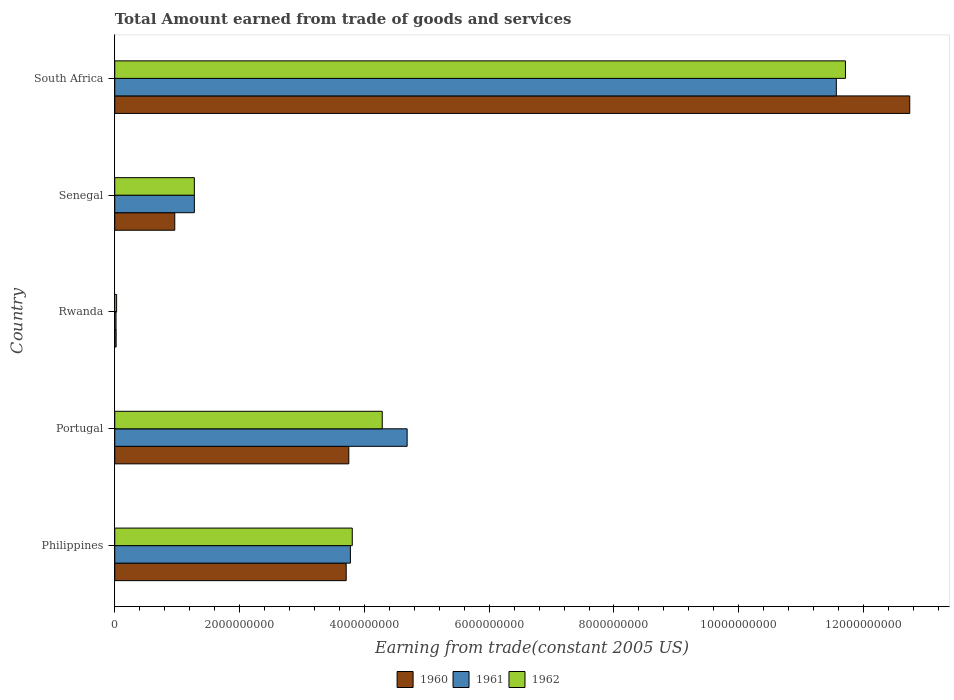How many groups of bars are there?
Your answer should be compact. 5. Are the number of bars per tick equal to the number of legend labels?
Provide a succinct answer. Yes. Are the number of bars on each tick of the Y-axis equal?
Your answer should be very brief. Yes. How many bars are there on the 3rd tick from the bottom?
Keep it short and to the point. 3. What is the label of the 1st group of bars from the top?
Provide a succinct answer. South Africa. In how many cases, is the number of bars for a given country not equal to the number of legend labels?
Your answer should be very brief. 0. What is the total amount earned by trading goods and services in 1962 in South Africa?
Provide a short and direct response. 1.17e+1. Across all countries, what is the maximum total amount earned by trading goods and services in 1961?
Your answer should be very brief. 1.16e+1. Across all countries, what is the minimum total amount earned by trading goods and services in 1962?
Provide a succinct answer. 2.97e+07. In which country was the total amount earned by trading goods and services in 1962 maximum?
Your response must be concise. South Africa. In which country was the total amount earned by trading goods and services in 1962 minimum?
Make the answer very short. Rwanda. What is the total total amount earned by trading goods and services in 1960 in the graph?
Offer a very short reply. 2.12e+1. What is the difference between the total amount earned by trading goods and services in 1962 in Philippines and that in South Africa?
Provide a succinct answer. -7.90e+09. What is the difference between the total amount earned by trading goods and services in 1960 in Philippines and the total amount earned by trading goods and services in 1961 in Portugal?
Your answer should be very brief. -9.77e+08. What is the average total amount earned by trading goods and services in 1960 per country?
Provide a short and direct response. 4.24e+09. What is the difference between the total amount earned by trading goods and services in 1961 and total amount earned by trading goods and services in 1962 in Rwanda?
Your answer should be compact. -9.20e+06. In how many countries, is the total amount earned by trading goods and services in 1961 greater than 6000000000 US$?
Provide a short and direct response. 1. What is the ratio of the total amount earned by trading goods and services in 1962 in Portugal to that in Rwanda?
Offer a terse response. 144.33. Is the total amount earned by trading goods and services in 1960 in Philippines less than that in Portugal?
Provide a succinct answer. Yes. What is the difference between the highest and the second highest total amount earned by trading goods and services in 1962?
Your answer should be very brief. 7.42e+09. What is the difference between the highest and the lowest total amount earned by trading goods and services in 1960?
Give a very brief answer. 1.27e+1. In how many countries, is the total amount earned by trading goods and services in 1960 greater than the average total amount earned by trading goods and services in 1960 taken over all countries?
Ensure brevity in your answer.  1. What does the 1st bar from the top in Philippines represents?
Your answer should be compact. 1962. What does the 3rd bar from the bottom in Rwanda represents?
Your answer should be compact. 1962. Is it the case that in every country, the sum of the total amount earned by trading goods and services in 1961 and total amount earned by trading goods and services in 1960 is greater than the total amount earned by trading goods and services in 1962?
Your answer should be very brief. Yes. How many bars are there?
Give a very brief answer. 15. How many countries are there in the graph?
Your answer should be very brief. 5. What is the difference between two consecutive major ticks on the X-axis?
Make the answer very short. 2.00e+09. Are the values on the major ticks of X-axis written in scientific E-notation?
Your answer should be very brief. No. Does the graph contain any zero values?
Offer a terse response. No. Does the graph contain grids?
Provide a succinct answer. No. Where does the legend appear in the graph?
Your answer should be very brief. Bottom center. How many legend labels are there?
Offer a terse response. 3. How are the legend labels stacked?
Keep it short and to the point. Horizontal. What is the title of the graph?
Provide a short and direct response. Total Amount earned from trade of goods and services. What is the label or title of the X-axis?
Ensure brevity in your answer.  Earning from trade(constant 2005 US). What is the Earning from trade(constant 2005 US) of 1960 in Philippines?
Offer a terse response. 3.71e+09. What is the Earning from trade(constant 2005 US) of 1961 in Philippines?
Your answer should be very brief. 3.78e+09. What is the Earning from trade(constant 2005 US) of 1962 in Philippines?
Your answer should be compact. 3.81e+09. What is the Earning from trade(constant 2005 US) of 1960 in Portugal?
Make the answer very short. 3.75e+09. What is the Earning from trade(constant 2005 US) of 1961 in Portugal?
Provide a succinct answer. 4.69e+09. What is the Earning from trade(constant 2005 US) of 1962 in Portugal?
Make the answer very short. 4.29e+09. What is the Earning from trade(constant 2005 US) of 1960 in Rwanda?
Your answer should be compact. 2.20e+07. What is the Earning from trade(constant 2005 US) in 1961 in Rwanda?
Offer a very short reply. 2.05e+07. What is the Earning from trade(constant 2005 US) of 1962 in Rwanda?
Your answer should be compact. 2.97e+07. What is the Earning from trade(constant 2005 US) in 1960 in Senegal?
Make the answer very short. 9.62e+08. What is the Earning from trade(constant 2005 US) in 1961 in Senegal?
Provide a succinct answer. 1.28e+09. What is the Earning from trade(constant 2005 US) in 1962 in Senegal?
Provide a short and direct response. 1.28e+09. What is the Earning from trade(constant 2005 US) of 1960 in South Africa?
Provide a short and direct response. 1.27e+1. What is the Earning from trade(constant 2005 US) of 1961 in South Africa?
Offer a terse response. 1.16e+1. What is the Earning from trade(constant 2005 US) of 1962 in South Africa?
Your answer should be very brief. 1.17e+1. Across all countries, what is the maximum Earning from trade(constant 2005 US) of 1960?
Ensure brevity in your answer.  1.27e+1. Across all countries, what is the maximum Earning from trade(constant 2005 US) of 1961?
Your answer should be compact. 1.16e+1. Across all countries, what is the maximum Earning from trade(constant 2005 US) in 1962?
Provide a succinct answer. 1.17e+1. Across all countries, what is the minimum Earning from trade(constant 2005 US) in 1960?
Offer a very short reply. 2.20e+07. Across all countries, what is the minimum Earning from trade(constant 2005 US) of 1961?
Give a very brief answer. 2.05e+07. Across all countries, what is the minimum Earning from trade(constant 2005 US) in 1962?
Offer a terse response. 2.97e+07. What is the total Earning from trade(constant 2005 US) in 1960 in the graph?
Make the answer very short. 2.12e+1. What is the total Earning from trade(constant 2005 US) in 1961 in the graph?
Offer a very short reply. 2.13e+1. What is the total Earning from trade(constant 2005 US) in 1962 in the graph?
Your answer should be very brief. 2.11e+1. What is the difference between the Earning from trade(constant 2005 US) of 1960 in Philippines and that in Portugal?
Offer a very short reply. -4.19e+07. What is the difference between the Earning from trade(constant 2005 US) in 1961 in Philippines and that in Portugal?
Keep it short and to the point. -9.10e+08. What is the difference between the Earning from trade(constant 2005 US) in 1962 in Philippines and that in Portugal?
Ensure brevity in your answer.  -4.80e+08. What is the difference between the Earning from trade(constant 2005 US) of 1960 in Philippines and that in Rwanda?
Offer a terse response. 3.69e+09. What is the difference between the Earning from trade(constant 2005 US) in 1961 in Philippines and that in Rwanda?
Make the answer very short. 3.76e+09. What is the difference between the Earning from trade(constant 2005 US) of 1962 in Philippines and that in Rwanda?
Give a very brief answer. 3.78e+09. What is the difference between the Earning from trade(constant 2005 US) in 1960 in Philippines and that in Senegal?
Ensure brevity in your answer.  2.75e+09. What is the difference between the Earning from trade(constant 2005 US) in 1961 in Philippines and that in Senegal?
Make the answer very short. 2.50e+09. What is the difference between the Earning from trade(constant 2005 US) of 1962 in Philippines and that in Senegal?
Offer a very short reply. 2.53e+09. What is the difference between the Earning from trade(constant 2005 US) of 1960 in Philippines and that in South Africa?
Your answer should be compact. -9.03e+09. What is the difference between the Earning from trade(constant 2005 US) of 1961 in Philippines and that in South Africa?
Ensure brevity in your answer.  -7.79e+09. What is the difference between the Earning from trade(constant 2005 US) in 1962 in Philippines and that in South Africa?
Your answer should be very brief. -7.90e+09. What is the difference between the Earning from trade(constant 2005 US) of 1960 in Portugal and that in Rwanda?
Keep it short and to the point. 3.73e+09. What is the difference between the Earning from trade(constant 2005 US) of 1961 in Portugal and that in Rwanda?
Provide a short and direct response. 4.67e+09. What is the difference between the Earning from trade(constant 2005 US) in 1962 in Portugal and that in Rwanda?
Offer a terse response. 4.26e+09. What is the difference between the Earning from trade(constant 2005 US) in 1960 in Portugal and that in Senegal?
Offer a very short reply. 2.79e+09. What is the difference between the Earning from trade(constant 2005 US) in 1961 in Portugal and that in Senegal?
Keep it short and to the point. 3.41e+09. What is the difference between the Earning from trade(constant 2005 US) in 1962 in Portugal and that in Senegal?
Keep it short and to the point. 3.01e+09. What is the difference between the Earning from trade(constant 2005 US) in 1960 in Portugal and that in South Africa?
Your answer should be very brief. -8.99e+09. What is the difference between the Earning from trade(constant 2005 US) in 1961 in Portugal and that in South Africa?
Give a very brief answer. -6.88e+09. What is the difference between the Earning from trade(constant 2005 US) of 1962 in Portugal and that in South Africa?
Provide a succinct answer. -7.42e+09. What is the difference between the Earning from trade(constant 2005 US) in 1960 in Rwanda and that in Senegal?
Your response must be concise. -9.40e+08. What is the difference between the Earning from trade(constant 2005 US) of 1961 in Rwanda and that in Senegal?
Your response must be concise. -1.26e+09. What is the difference between the Earning from trade(constant 2005 US) of 1962 in Rwanda and that in Senegal?
Offer a very short reply. -1.25e+09. What is the difference between the Earning from trade(constant 2005 US) of 1960 in Rwanda and that in South Africa?
Ensure brevity in your answer.  -1.27e+1. What is the difference between the Earning from trade(constant 2005 US) in 1961 in Rwanda and that in South Africa?
Offer a very short reply. -1.15e+1. What is the difference between the Earning from trade(constant 2005 US) in 1962 in Rwanda and that in South Africa?
Give a very brief answer. -1.17e+1. What is the difference between the Earning from trade(constant 2005 US) in 1960 in Senegal and that in South Africa?
Your response must be concise. -1.18e+1. What is the difference between the Earning from trade(constant 2005 US) in 1961 in Senegal and that in South Africa?
Ensure brevity in your answer.  -1.03e+1. What is the difference between the Earning from trade(constant 2005 US) in 1962 in Senegal and that in South Africa?
Keep it short and to the point. -1.04e+1. What is the difference between the Earning from trade(constant 2005 US) of 1960 in Philippines and the Earning from trade(constant 2005 US) of 1961 in Portugal?
Give a very brief answer. -9.77e+08. What is the difference between the Earning from trade(constant 2005 US) of 1960 in Philippines and the Earning from trade(constant 2005 US) of 1962 in Portugal?
Your answer should be compact. -5.78e+08. What is the difference between the Earning from trade(constant 2005 US) in 1961 in Philippines and the Earning from trade(constant 2005 US) in 1962 in Portugal?
Give a very brief answer. -5.11e+08. What is the difference between the Earning from trade(constant 2005 US) in 1960 in Philippines and the Earning from trade(constant 2005 US) in 1961 in Rwanda?
Offer a terse response. 3.69e+09. What is the difference between the Earning from trade(constant 2005 US) in 1960 in Philippines and the Earning from trade(constant 2005 US) in 1962 in Rwanda?
Provide a short and direct response. 3.68e+09. What is the difference between the Earning from trade(constant 2005 US) of 1961 in Philippines and the Earning from trade(constant 2005 US) of 1962 in Rwanda?
Provide a succinct answer. 3.75e+09. What is the difference between the Earning from trade(constant 2005 US) of 1960 in Philippines and the Earning from trade(constant 2005 US) of 1961 in Senegal?
Your response must be concise. 2.43e+09. What is the difference between the Earning from trade(constant 2005 US) of 1960 in Philippines and the Earning from trade(constant 2005 US) of 1962 in Senegal?
Keep it short and to the point. 2.43e+09. What is the difference between the Earning from trade(constant 2005 US) of 1961 in Philippines and the Earning from trade(constant 2005 US) of 1962 in Senegal?
Ensure brevity in your answer.  2.50e+09. What is the difference between the Earning from trade(constant 2005 US) of 1960 in Philippines and the Earning from trade(constant 2005 US) of 1961 in South Africa?
Offer a terse response. -7.85e+09. What is the difference between the Earning from trade(constant 2005 US) of 1960 in Philippines and the Earning from trade(constant 2005 US) of 1962 in South Africa?
Your answer should be very brief. -8.00e+09. What is the difference between the Earning from trade(constant 2005 US) in 1961 in Philippines and the Earning from trade(constant 2005 US) in 1962 in South Africa?
Ensure brevity in your answer.  -7.93e+09. What is the difference between the Earning from trade(constant 2005 US) of 1960 in Portugal and the Earning from trade(constant 2005 US) of 1961 in Rwanda?
Your answer should be very brief. 3.73e+09. What is the difference between the Earning from trade(constant 2005 US) of 1960 in Portugal and the Earning from trade(constant 2005 US) of 1962 in Rwanda?
Make the answer very short. 3.72e+09. What is the difference between the Earning from trade(constant 2005 US) in 1961 in Portugal and the Earning from trade(constant 2005 US) in 1962 in Rwanda?
Ensure brevity in your answer.  4.66e+09. What is the difference between the Earning from trade(constant 2005 US) in 1960 in Portugal and the Earning from trade(constant 2005 US) in 1961 in Senegal?
Provide a succinct answer. 2.48e+09. What is the difference between the Earning from trade(constant 2005 US) of 1960 in Portugal and the Earning from trade(constant 2005 US) of 1962 in Senegal?
Give a very brief answer. 2.48e+09. What is the difference between the Earning from trade(constant 2005 US) in 1961 in Portugal and the Earning from trade(constant 2005 US) in 1962 in Senegal?
Give a very brief answer. 3.41e+09. What is the difference between the Earning from trade(constant 2005 US) of 1960 in Portugal and the Earning from trade(constant 2005 US) of 1961 in South Africa?
Provide a succinct answer. -7.81e+09. What is the difference between the Earning from trade(constant 2005 US) in 1960 in Portugal and the Earning from trade(constant 2005 US) in 1962 in South Africa?
Your response must be concise. -7.96e+09. What is the difference between the Earning from trade(constant 2005 US) of 1961 in Portugal and the Earning from trade(constant 2005 US) of 1962 in South Africa?
Your response must be concise. -7.02e+09. What is the difference between the Earning from trade(constant 2005 US) of 1960 in Rwanda and the Earning from trade(constant 2005 US) of 1961 in Senegal?
Ensure brevity in your answer.  -1.25e+09. What is the difference between the Earning from trade(constant 2005 US) of 1960 in Rwanda and the Earning from trade(constant 2005 US) of 1962 in Senegal?
Provide a succinct answer. -1.25e+09. What is the difference between the Earning from trade(constant 2005 US) in 1961 in Rwanda and the Earning from trade(constant 2005 US) in 1962 in Senegal?
Offer a very short reply. -1.26e+09. What is the difference between the Earning from trade(constant 2005 US) in 1960 in Rwanda and the Earning from trade(constant 2005 US) in 1961 in South Africa?
Ensure brevity in your answer.  -1.15e+1. What is the difference between the Earning from trade(constant 2005 US) of 1960 in Rwanda and the Earning from trade(constant 2005 US) of 1962 in South Africa?
Your response must be concise. -1.17e+1. What is the difference between the Earning from trade(constant 2005 US) in 1961 in Rwanda and the Earning from trade(constant 2005 US) in 1962 in South Africa?
Provide a short and direct response. -1.17e+1. What is the difference between the Earning from trade(constant 2005 US) in 1960 in Senegal and the Earning from trade(constant 2005 US) in 1961 in South Africa?
Your answer should be very brief. -1.06e+1. What is the difference between the Earning from trade(constant 2005 US) in 1960 in Senegal and the Earning from trade(constant 2005 US) in 1962 in South Africa?
Provide a short and direct response. -1.07e+1. What is the difference between the Earning from trade(constant 2005 US) of 1961 in Senegal and the Earning from trade(constant 2005 US) of 1962 in South Africa?
Give a very brief answer. -1.04e+1. What is the average Earning from trade(constant 2005 US) in 1960 per country?
Offer a terse response. 4.24e+09. What is the average Earning from trade(constant 2005 US) of 1961 per country?
Give a very brief answer. 4.26e+09. What is the average Earning from trade(constant 2005 US) in 1962 per country?
Your response must be concise. 4.22e+09. What is the difference between the Earning from trade(constant 2005 US) of 1960 and Earning from trade(constant 2005 US) of 1961 in Philippines?
Your answer should be very brief. -6.71e+07. What is the difference between the Earning from trade(constant 2005 US) of 1960 and Earning from trade(constant 2005 US) of 1962 in Philippines?
Offer a terse response. -9.73e+07. What is the difference between the Earning from trade(constant 2005 US) in 1961 and Earning from trade(constant 2005 US) in 1962 in Philippines?
Offer a terse response. -3.02e+07. What is the difference between the Earning from trade(constant 2005 US) of 1960 and Earning from trade(constant 2005 US) of 1961 in Portugal?
Offer a very short reply. -9.35e+08. What is the difference between the Earning from trade(constant 2005 US) in 1960 and Earning from trade(constant 2005 US) in 1962 in Portugal?
Make the answer very short. -5.36e+08. What is the difference between the Earning from trade(constant 2005 US) of 1961 and Earning from trade(constant 2005 US) of 1962 in Portugal?
Your answer should be very brief. 3.99e+08. What is the difference between the Earning from trade(constant 2005 US) of 1960 and Earning from trade(constant 2005 US) of 1961 in Rwanda?
Your response must be concise. 1.46e+06. What is the difference between the Earning from trade(constant 2005 US) in 1960 and Earning from trade(constant 2005 US) in 1962 in Rwanda?
Give a very brief answer. -7.74e+06. What is the difference between the Earning from trade(constant 2005 US) of 1961 and Earning from trade(constant 2005 US) of 1962 in Rwanda?
Your answer should be compact. -9.20e+06. What is the difference between the Earning from trade(constant 2005 US) in 1960 and Earning from trade(constant 2005 US) in 1961 in Senegal?
Your answer should be very brief. -3.14e+08. What is the difference between the Earning from trade(constant 2005 US) in 1960 and Earning from trade(constant 2005 US) in 1962 in Senegal?
Ensure brevity in your answer.  -3.14e+08. What is the difference between the Earning from trade(constant 2005 US) of 1961 and Earning from trade(constant 2005 US) of 1962 in Senegal?
Make the answer very short. 0. What is the difference between the Earning from trade(constant 2005 US) of 1960 and Earning from trade(constant 2005 US) of 1961 in South Africa?
Keep it short and to the point. 1.18e+09. What is the difference between the Earning from trade(constant 2005 US) of 1960 and Earning from trade(constant 2005 US) of 1962 in South Africa?
Ensure brevity in your answer.  1.03e+09. What is the difference between the Earning from trade(constant 2005 US) in 1961 and Earning from trade(constant 2005 US) in 1962 in South Africa?
Offer a terse response. -1.46e+08. What is the ratio of the Earning from trade(constant 2005 US) in 1961 in Philippines to that in Portugal?
Keep it short and to the point. 0.81. What is the ratio of the Earning from trade(constant 2005 US) in 1962 in Philippines to that in Portugal?
Your response must be concise. 0.89. What is the ratio of the Earning from trade(constant 2005 US) in 1960 in Philippines to that in Rwanda?
Make the answer very short. 168.89. What is the ratio of the Earning from trade(constant 2005 US) of 1961 in Philippines to that in Rwanda?
Keep it short and to the point. 184.2. What is the ratio of the Earning from trade(constant 2005 US) in 1962 in Philippines to that in Rwanda?
Your answer should be very brief. 128.15. What is the ratio of the Earning from trade(constant 2005 US) in 1960 in Philippines to that in Senegal?
Your answer should be compact. 3.86. What is the ratio of the Earning from trade(constant 2005 US) of 1961 in Philippines to that in Senegal?
Provide a short and direct response. 2.96. What is the ratio of the Earning from trade(constant 2005 US) in 1962 in Philippines to that in Senegal?
Provide a succinct answer. 2.98. What is the ratio of the Earning from trade(constant 2005 US) of 1960 in Philippines to that in South Africa?
Your answer should be compact. 0.29. What is the ratio of the Earning from trade(constant 2005 US) in 1961 in Philippines to that in South Africa?
Provide a short and direct response. 0.33. What is the ratio of the Earning from trade(constant 2005 US) in 1962 in Philippines to that in South Africa?
Your answer should be compact. 0.33. What is the ratio of the Earning from trade(constant 2005 US) in 1960 in Portugal to that in Rwanda?
Your response must be concise. 170.8. What is the ratio of the Earning from trade(constant 2005 US) of 1961 in Portugal to that in Rwanda?
Provide a succinct answer. 228.56. What is the ratio of the Earning from trade(constant 2005 US) of 1962 in Portugal to that in Rwanda?
Provide a succinct answer. 144.33. What is the ratio of the Earning from trade(constant 2005 US) of 1960 in Portugal to that in Senegal?
Give a very brief answer. 3.9. What is the ratio of the Earning from trade(constant 2005 US) in 1961 in Portugal to that in Senegal?
Provide a short and direct response. 3.67. What is the ratio of the Earning from trade(constant 2005 US) in 1962 in Portugal to that in Senegal?
Your response must be concise. 3.36. What is the ratio of the Earning from trade(constant 2005 US) of 1960 in Portugal to that in South Africa?
Ensure brevity in your answer.  0.29. What is the ratio of the Earning from trade(constant 2005 US) of 1961 in Portugal to that in South Africa?
Provide a short and direct response. 0.41. What is the ratio of the Earning from trade(constant 2005 US) of 1962 in Portugal to that in South Africa?
Offer a terse response. 0.37. What is the ratio of the Earning from trade(constant 2005 US) in 1960 in Rwanda to that in Senegal?
Offer a very short reply. 0.02. What is the ratio of the Earning from trade(constant 2005 US) in 1961 in Rwanda to that in Senegal?
Provide a succinct answer. 0.02. What is the ratio of the Earning from trade(constant 2005 US) of 1962 in Rwanda to that in Senegal?
Your answer should be compact. 0.02. What is the ratio of the Earning from trade(constant 2005 US) of 1960 in Rwanda to that in South Africa?
Your answer should be compact. 0. What is the ratio of the Earning from trade(constant 2005 US) of 1961 in Rwanda to that in South Africa?
Your response must be concise. 0. What is the ratio of the Earning from trade(constant 2005 US) of 1962 in Rwanda to that in South Africa?
Your response must be concise. 0. What is the ratio of the Earning from trade(constant 2005 US) in 1960 in Senegal to that in South Africa?
Your answer should be very brief. 0.08. What is the ratio of the Earning from trade(constant 2005 US) of 1961 in Senegal to that in South Africa?
Ensure brevity in your answer.  0.11. What is the ratio of the Earning from trade(constant 2005 US) in 1962 in Senegal to that in South Africa?
Provide a short and direct response. 0.11. What is the difference between the highest and the second highest Earning from trade(constant 2005 US) of 1960?
Your answer should be compact. 8.99e+09. What is the difference between the highest and the second highest Earning from trade(constant 2005 US) of 1961?
Offer a terse response. 6.88e+09. What is the difference between the highest and the second highest Earning from trade(constant 2005 US) of 1962?
Ensure brevity in your answer.  7.42e+09. What is the difference between the highest and the lowest Earning from trade(constant 2005 US) of 1960?
Your response must be concise. 1.27e+1. What is the difference between the highest and the lowest Earning from trade(constant 2005 US) of 1961?
Offer a terse response. 1.15e+1. What is the difference between the highest and the lowest Earning from trade(constant 2005 US) in 1962?
Your answer should be very brief. 1.17e+1. 